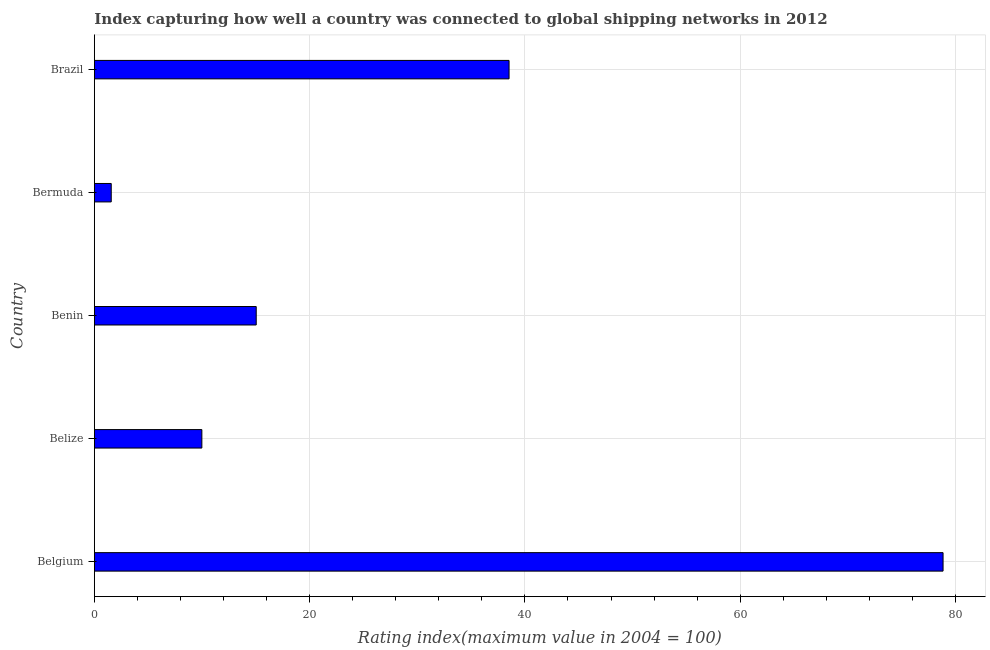Does the graph contain any zero values?
Give a very brief answer. No. What is the title of the graph?
Offer a very short reply. Index capturing how well a country was connected to global shipping networks in 2012. What is the label or title of the X-axis?
Ensure brevity in your answer.  Rating index(maximum value in 2004 = 100). What is the liner shipping connectivity index in Brazil?
Give a very brief answer. 38.53. Across all countries, what is the maximum liner shipping connectivity index?
Provide a succinct answer. 78.85. Across all countries, what is the minimum liner shipping connectivity index?
Give a very brief answer. 1.57. In which country was the liner shipping connectivity index maximum?
Provide a short and direct response. Belgium. In which country was the liner shipping connectivity index minimum?
Your response must be concise. Bermuda. What is the sum of the liner shipping connectivity index?
Give a very brief answer. 143.98. What is the difference between the liner shipping connectivity index in Belgium and Bermuda?
Your answer should be compact. 77.28. What is the average liner shipping connectivity index per country?
Give a very brief answer. 28.8. What is the median liner shipping connectivity index?
Keep it short and to the point. 15.04. What is the ratio of the liner shipping connectivity index in Benin to that in Brazil?
Provide a succinct answer. 0.39. Is the liner shipping connectivity index in Belgium less than that in Benin?
Make the answer very short. No. Is the difference between the liner shipping connectivity index in Belgium and Benin greater than the difference between any two countries?
Offer a very short reply. No. What is the difference between the highest and the second highest liner shipping connectivity index?
Keep it short and to the point. 40.32. What is the difference between the highest and the lowest liner shipping connectivity index?
Give a very brief answer. 77.28. In how many countries, is the liner shipping connectivity index greater than the average liner shipping connectivity index taken over all countries?
Provide a short and direct response. 2. Are all the bars in the graph horizontal?
Ensure brevity in your answer.  Yes. What is the difference between two consecutive major ticks on the X-axis?
Provide a short and direct response. 20. What is the Rating index(maximum value in 2004 = 100) in Belgium?
Offer a very short reply. 78.85. What is the Rating index(maximum value in 2004 = 100) of Belize?
Keep it short and to the point. 9.99. What is the Rating index(maximum value in 2004 = 100) in Benin?
Your answer should be very brief. 15.04. What is the Rating index(maximum value in 2004 = 100) of Bermuda?
Provide a succinct answer. 1.57. What is the Rating index(maximum value in 2004 = 100) of Brazil?
Provide a succinct answer. 38.53. What is the difference between the Rating index(maximum value in 2004 = 100) in Belgium and Belize?
Keep it short and to the point. 68.86. What is the difference between the Rating index(maximum value in 2004 = 100) in Belgium and Benin?
Offer a terse response. 63.81. What is the difference between the Rating index(maximum value in 2004 = 100) in Belgium and Bermuda?
Your answer should be very brief. 77.28. What is the difference between the Rating index(maximum value in 2004 = 100) in Belgium and Brazil?
Make the answer very short. 40.32. What is the difference between the Rating index(maximum value in 2004 = 100) in Belize and Benin?
Offer a terse response. -5.05. What is the difference between the Rating index(maximum value in 2004 = 100) in Belize and Bermuda?
Provide a succinct answer. 8.42. What is the difference between the Rating index(maximum value in 2004 = 100) in Belize and Brazil?
Your response must be concise. -28.54. What is the difference between the Rating index(maximum value in 2004 = 100) in Benin and Bermuda?
Make the answer very short. 13.47. What is the difference between the Rating index(maximum value in 2004 = 100) in Benin and Brazil?
Give a very brief answer. -23.49. What is the difference between the Rating index(maximum value in 2004 = 100) in Bermuda and Brazil?
Offer a terse response. -36.96. What is the ratio of the Rating index(maximum value in 2004 = 100) in Belgium to that in Belize?
Keep it short and to the point. 7.89. What is the ratio of the Rating index(maximum value in 2004 = 100) in Belgium to that in Benin?
Keep it short and to the point. 5.24. What is the ratio of the Rating index(maximum value in 2004 = 100) in Belgium to that in Bermuda?
Offer a very short reply. 50.22. What is the ratio of the Rating index(maximum value in 2004 = 100) in Belgium to that in Brazil?
Your answer should be very brief. 2.05. What is the ratio of the Rating index(maximum value in 2004 = 100) in Belize to that in Benin?
Ensure brevity in your answer.  0.66. What is the ratio of the Rating index(maximum value in 2004 = 100) in Belize to that in Bermuda?
Offer a very short reply. 6.36. What is the ratio of the Rating index(maximum value in 2004 = 100) in Belize to that in Brazil?
Your answer should be very brief. 0.26. What is the ratio of the Rating index(maximum value in 2004 = 100) in Benin to that in Bermuda?
Offer a very short reply. 9.58. What is the ratio of the Rating index(maximum value in 2004 = 100) in Benin to that in Brazil?
Provide a short and direct response. 0.39. What is the ratio of the Rating index(maximum value in 2004 = 100) in Bermuda to that in Brazil?
Your answer should be compact. 0.04. 